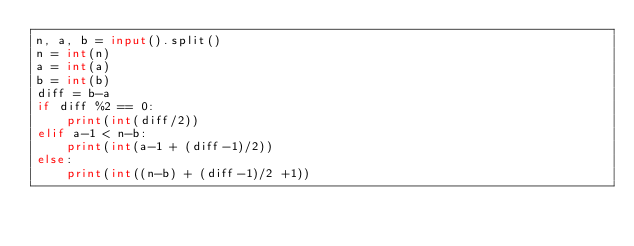Convert code to text. <code><loc_0><loc_0><loc_500><loc_500><_Python_>n, a, b = input().split()
n = int(n)
a = int(a)
b = int(b)
diff = b-a
if diff %2 == 0:
    print(int(diff/2))
elif a-1 < n-b:
    print(int(a-1 + (diff-1)/2))
else:
    print(int((n-b) + (diff-1)/2 +1))</code> 